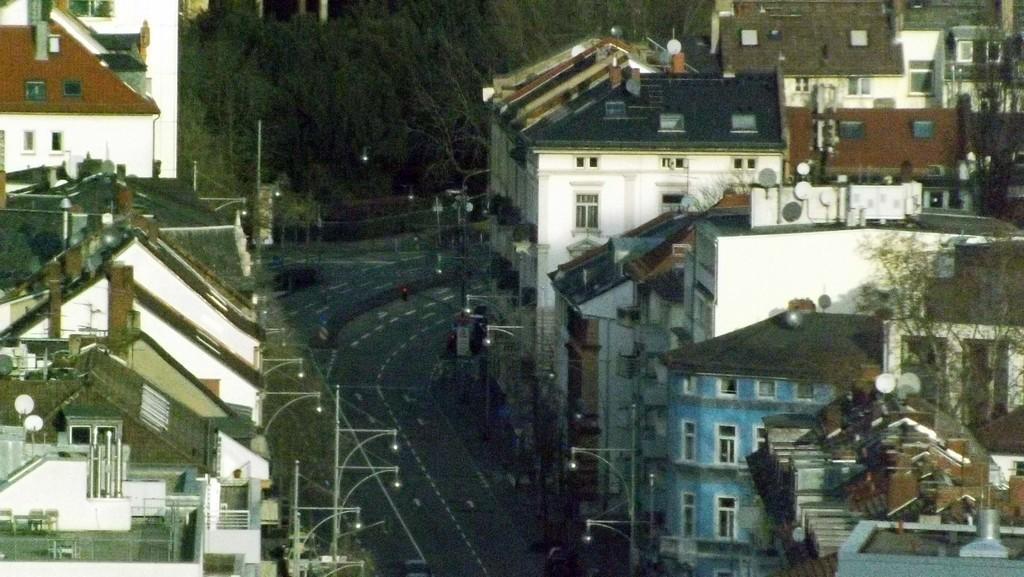How would you summarize this image in a sentence or two? In this image we can see some buildings, on the buildings we can see there are some dish tv's, there are some windows, poles, lights and trees. 